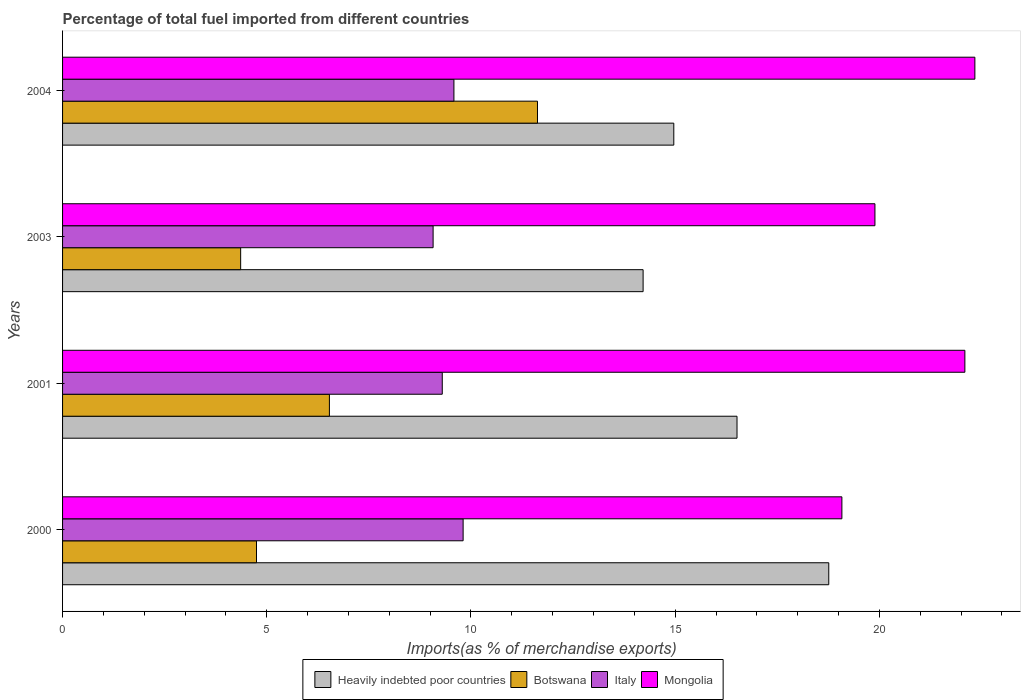How many different coloured bars are there?
Provide a short and direct response. 4. How many groups of bars are there?
Your answer should be very brief. 4. Are the number of bars per tick equal to the number of legend labels?
Provide a short and direct response. Yes. Are the number of bars on each tick of the Y-axis equal?
Give a very brief answer. Yes. What is the label of the 1st group of bars from the top?
Make the answer very short. 2004. What is the percentage of imports to different countries in Botswana in 2000?
Your response must be concise. 4.75. Across all years, what is the maximum percentage of imports to different countries in Mongolia?
Offer a very short reply. 22.34. Across all years, what is the minimum percentage of imports to different countries in Heavily indebted poor countries?
Keep it short and to the point. 14.21. What is the total percentage of imports to different countries in Heavily indebted poor countries in the graph?
Make the answer very short. 64.46. What is the difference between the percentage of imports to different countries in Mongolia in 2001 and that in 2004?
Your answer should be compact. -0.25. What is the difference between the percentage of imports to different countries in Mongolia in 2004 and the percentage of imports to different countries in Botswana in 2003?
Make the answer very short. 17.98. What is the average percentage of imports to different countries in Botswana per year?
Provide a succinct answer. 6.82. In the year 2000, what is the difference between the percentage of imports to different countries in Botswana and percentage of imports to different countries in Italy?
Your response must be concise. -5.06. What is the ratio of the percentage of imports to different countries in Heavily indebted poor countries in 2000 to that in 2001?
Give a very brief answer. 1.14. What is the difference between the highest and the second highest percentage of imports to different countries in Italy?
Provide a succinct answer. 0.23. What is the difference between the highest and the lowest percentage of imports to different countries in Heavily indebted poor countries?
Give a very brief answer. 4.55. Is the sum of the percentage of imports to different countries in Italy in 2003 and 2004 greater than the maximum percentage of imports to different countries in Mongolia across all years?
Provide a succinct answer. No. Is it the case that in every year, the sum of the percentage of imports to different countries in Botswana and percentage of imports to different countries in Italy is greater than the sum of percentage of imports to different countries in Mongolia and percentage of imports to different countries in Heavily indebted poor countries?
Offer a very short reply. No. What does the 3rd bar from the top in 2004 represents?
Make the answer very short. Botswana. What does the 1st bar from the bottom in 2001 represents?
Your answer should be compact. Heavily indebted poor countries. Are all the bars in the graph horizontal?
Your answer should be compact. Yes. Are the values on the major ticks of X-axis written in scientific E-notation?
Provide a succinct answer. No. Does the graph contain any zero values?
Offer a very short reply. No. Where does the legend appear in the graph?
Offer a very short reply. Bottom center. How many legend labels are there?
Provide a short and direct response. 4. What is the title of the graph?
Your response must be concise. Percentage of total fuel imported from different countries. What is the label or title of the X-axis?
Your answer should be compact. Imports(as % of merchandise exports). What is the Imports(as % of merchandise exports) of Heavily indebted poor countries in 2000?
Keep it short and to the point. 18.76. What is the Imports(as % of merchandise exports) in Botswana in 2000?
Your answer should be compact. 4.75. What is the Imports(as % of merchandise exports) of Italy in 2000?
Offer a very short reply. 9.81. What is the Imports(as % of merchandise exports) of Mongolia in 2000?
Provide a succinct answer. 19.08. What is the Imports(as % of merchandise exports) of Heavily indebted poor countries in 2001?
Keep it short and to the point. 16.51. What is the Imports(as % of merchandise exports) in Botswana in 2001?
Make the answer very short. 6.53. What is the Imports(as % of merchandise exports) of Italy in 2001?
Make the answer very short. 9.3. What is the Imports(as % of merchandise exports) in Mongolia in 2001?
Give a very brief answer. 22.09. What is the Imports(as % of merchandise exports) of Heavily indebted poor countries in 2003?
Keep it short and to the point. 14.21. What is the Imports(as % of merchandise exports) of Botswana in 2003?
Give a very brief answer. 4.36. What is the Imports(as % of merchandise exports) in Italy in 2003?
Your answer should be very brief. 9.07. What is the Imports(as % of merchandise exports) in Mongolia in 2003?
Keep it short and to the point. 19.89. What is the Imports(as % of merchandise exports) in Heavily indebted poor countries in 2004?
Make the answer very short. 14.97. What is the Imports(as % of merchandise exports) of Botswana in 2004?
Ensure brevity in your answer.  11.63. What is the Imports(as % of merchandise exports) of Italy in 2004?
Ensure brevity in your answer.  9.58. What is the Imports(as % of merchandise exports) in Mongolia in 2004?
Provide a succinct answer. 22.34. Across all years, what is the maximum Imports(as % of merchandise exports) of Heavily indebted poor countries?
Offer a terse response. 18.76. Across all years, what is the maximum Imports(as % of merchandise exports) of Botswana?
Your answer should be compact. 11.63. Across all years, what is the maximum Imports(as % of merchandise exports) of Italy?
Your answer should be very brief. 9.81. Across all years, what is the maximum Imports(as % of merchandise exports) in Mongolia?
Ensure brevity in your answer.  22.34. Across all years, what is the minimum Imports(as % of merchandise exports) of Heavily indebted poor countries?
Keep it short and to the point. 14.21. Across all years, what is the minimum Imports(as % of merchandise exports) in Botswana?
Your answer should be compact. 4.36. Across all years, what is the minimum Imports(as % of merchandise exports) of Italy?
Give a very brief answer. 9.07. Across all years, what is the minimum Imports(as % of merchandise exports) in Mongolia?
Provide a succinct answer. 19.08. What is the total Imports(as % of merchandise exports) in Heavily indebted poor countries in the graph?
Offer a terse response. 64.46. What is the total Imports(as % of merchandise exports) of Botswana in the graph?
Keep it short and to the point. 27.27. What is the total Imports(as % of merchandise exports) in Italy in the graph?
Keep it short and to the point. 37.76. What is the total Imports(as % of merchandise exports) in Mongolia in the graph?
Your answer should be very brief. 83.41. What is the difference between the Imports(as % of merchandise exports) of Heavily indebted poor countries in 2000 and that in 2001?
Keep it short and to the point. 2.25. What is the difference between the Imports(as % of merchandise exports) in Botswana in 2000 and that in 2001?
Your answer should be compact. -1.79. What is the difference between the Imports(as % of merchandise exports) in Italy in 2000 and that in 2001?
Keep it short and to the point. 0.51. What is the difference between the Imports(as % of merchandise exports) of Mongolia in 2000 and that in 2001?
Provide a succinct answer. -3.01. What is the difference between the Imports(as % of merchandise exports) in Heavily indebted poor countries in 2000 and that in 2003?
Your answer should be compact. 4.55. What is the difference between the Imports(as % of merchandise exports) in Botswana in 2000 and that in 2003?
Ensure brevity in your answer.  0.39. What is the difference between the Imports(as % of merchandise exports) in Italy in 2000 and that in 2003?
Offer a very short reply. 0.74. What is the difference between the Imports(as % of merchandise exports) in Mongolia in 2000 and that in 2003?
Offer a terse response. -0.81. What is the difference between the Imports(as % of merchandise exports) of Heavily indebted poor countries in 2000 and that in 2004?
Your response must be concise. 3.79. What is the difference between the Imports(as % of merchandise exports) of Botswana in 2000 and that in 2004?
Your answer should be compact. -6.88. What is the difference between the Imports(as % of merchandise exports) in Italy in 2000 and that in 2004?
Your answer should be very brief. 0.23. What is the difference between the Imports(as % of merchandise exports) in Mongolia in 2000 and that in 2004?
Offer a very short reply. -3.26. What is the difference between the Imports(as % of merchandise exports) in Heavily indebted poor countries in 2001 and that in 2003?
Your answer should be very brief. 2.3. What is the difference between the Imports(as % of merchandise exports) of Botswana in 2001 and that in 2003?
Your answer should be very brief. 2.17. What is the difference between the Imports(as % of merchandise exports) in Italy in 2001 and that in 2003?
Keep it short and to the point. 0.22. What is the difference between the Imports(as % of merchandise exports) in Mongolia in 2001 and that in 2003?
Provide a succinct answer. 2.2. What is the difference between the Imports(as % of merchandise exports) of Heavily indebted poor countries in 2001 and that in 2004?
Provide a short and direct response. 1.55. What is the difference between the Imports(as % of merchandise exports) in Botswana in 2001 and that in 2004?
Make the answer very short. -5.09. What is the difference between the Imports(as % of merchandise exports) of Italy in 2001 and that in 2004?
Keep it short and to the point. -0.29. What is the difference between the Imports(as % of merchandise exports) of Mongolia in 2001 and that in 2004?
Keep it short and to the point. -0.24. What is the difference between the Imports(as % of merchandise exports) in Heavily indebted poor countries in 2003 and that in 2004?
Offer a very short reply. -0.75. What is the difference between the Imports(as % of merchandise exports) of Botswana in 2003 and that in 2004?
Your answer should be very brief. -7.27. What is the difference between the Imports(as % of merchandise exports) of Italy in 2003 and that in 2004?
Your answer should be compact. -0.51. What is the difference between the Imports(as % of merchandise exports) of Mongolia in 2003 and that in 2004?
Provide a succinct answer. -2.45. What is the difference between the Imports(as % of merchandise exports) in Heavily indebted poor countries in 2000 and the Imports(as % of merchandise exports) in Botswana in 2001?
Your answer should be very brief. 12.23. What is the difference between the Imports(as % of merchandise exports) in Heavily indebted poor countries in 2000 and the Imports(as % of merchandise exports) in Italy in 2001?
Provide a succinct answer. 9.46. What is the difference between the Imports(as % of merchandise exports) in Heavily indebted poor countries in 2000 and the Imports(as % of merchandise exports) in Mongolia in 2001?
Provide a succinct answer. -3.33. What is the difference between the Imports(as % of merchandise exports) in Botswana in 2000 and the Imports(as % of merchandise exports) in Italy in 2001?
Offer a very short reply. -4.55. What is the difference between the Imports(as % of merchandise exports) in Botswana in 2000 and the Imports(as % of merchandise exports) in Mongolia in 2001?
Ensure brevity in your answer.  -17.34. What is the difference between the Imports(as % of merchandise exports) in Italy in 2000 and the Imports(as % of merchandise exports) in Mongolia in 2001?
Provide a short and direct response. -12.29. What is the difference between the Imports(as % of merchandise exports) in Heavily indebted poor countries in 2000 and the Imports(as % of merchandise exports) in Botswana in 2003?
Your answer should be very brief. 14.4. What is the difference between the Imports(as % of merchandise exports) in Heavily indebted poor countries in 2000 and the Imports(as % of merchandise exports) in Italy in 2003?
Make the answer very short. 9.69. What is the difference between the Imports(as % of merchandise exports) in Heavily indebted poor countries in 2000 and the Imports(as % of merchandise exports) in Mongolia in 2003?
Offer a terse response. -1.13. What is the difference between the Imports(as % of merchandise exports) in Botswana in 2000 and the Imports(as % of merchandise exports) in Italy in 2003?
Provide a short and direct response. -4.32. What is the difference between the Imports(as % of merchandise exports) in Botswana in 2000 and the Imports(as % of merchandise exports) in Mongolia in 2003?
Provide a short and direct response. -15.14. What is the difference between the Imports(as % of merchandise exports) of Italy in 2000 and the Imports(as % of merchandise exports) of Mongolia in 2003?
Offer a very short reply. -10.08. What is the difference between the Imports(as % of merchandise exports) of Heavily indebted poor countries in 2000 and the Imports(as % of merchandise exports) of Botswana in 2004?
Keep it short and to the point. 7.13. What is the difference between the Imports(as % of merchandise exports) of Heavily indebted poor countries in 2000 and the Imports(as % of merchandise exports) of Italy in 2004?
Ensure brevity in your answer.  9.18. What is the difference between the Imports(as % of merchandise exports) in Heavily indebted poor countries in 2000 and the Imports(as % of merchandise exports) in Mongolia in 2004?
Your answer should be compact. -3.58. What is the difference between the Imports(as % of merchandise exports) of Botswana in 2000 and the Imports(as % of merchandise exports) of Italy in 2004?
Your answer should be compact. -4.83. What is the difference between the Imports(as % of merchandise exports) in Botswana in 2000 and the Imports(as % of merchandise exports) in Mongolia in 2004?
Keep it short and to the point. -17.59. What is the difference between the Imports(as % of merchandise exports) of Italy in 2000 and the Imports(as % of merchandise exports) of Mongolia in 2004?
Give a very brief answer. -12.53. What is the difference between the Imports(as % of merchandise exports) of Heavily indebted poor countries in 2001 and the Imports(as % of merchandise exports) of Botswana in 2003?
Make the answer very short. 12.15. What is the difference between the Imports(as % of merchandise exports) in Heavily indebted poor countries in 2001 and the Imports(as % of merchandise exports) in Italy in 2003?
Give a very brief answer. 7.44. What is the difference between the Imports(as % of merchandise exports) of Heavily indebted poor countries in 2001 and the Imports(as % of merchandise exports) of Mongolia in 2003?
Ensure brevity in your answer.  -3.38. What is the difference between the Imports(as % of merchandise exports) in Botswana in 2001 and the Imports(as % of merchandise exports) in Italy in 2003?
Give a very brief answer. -2.54. What is the difference between the Imports(as % of merchandise exports) in Botswana in 2001 and the Imports(as % of merchandise exports) in Mongolia in 2003?
Your response must be concise. -13.36. What is the difference between the Imports(as % of merchandise exports) in Italy in 2001 and the Imports(as % of merchandise exports) in Mongolia in 2003?
Make the answer very short. -10.59. What is the difference between the Imports(as % of merchandise exports) in Heavily indebted poor countries in 2001 and the Imports(as % of merchandise exports) in Botswana in 2004?
Ensure brevity in your answer.  4.89. What is the difference between the Imports(as % of merchandise exports) in Heavily indebted poor countries in 2001 and the Imports(as % of merchandise exports) in Italy in 2004?
Give a very brief answer. 6.93. What is the difference between the Imports(as % of merchandise exports) of Heavily indebted poor countries in 2001 and the Imports(as % of merchandise exports) of Mongolia in 2004?
Your response must be concise. -5.82. What is the difference between the Imports(as % of merchandise exports) in Botswana in 2001 and the Imports(as % of merchandise exports) in Italy in 2004?
Your answer should be very brief. -3.05. What is the difference between the Imports(as % of merchandise exports) of Botswana in 2001 and the Imports(as % of merchandise exports) of Mongolia in 2004?
Your answer should be compact. -15.8. What is the difference between the Imports(as % of merchandise exports) of Italy in 2001 and the Imports(as % of merchandise exports) of Mongolia in 2004?
Your response must be concise. -13.04. What is the difference between the Imports(as % of merchandise exports) of Heavily indebted poor countries in 2003 and the Imports(as % of merchandise exports) of Botswana in 2004?
Your answer should be very brief. 2.59. What is the difference between the Imports(as % of merchandise exports) in Heavily indebted poor countries in 2003 and the Imports(as % of merchandise exports) in Italy in 2004?
Offer a terse response. 4.63. What is the difference between the Imports(as % of merchandise exports) in Heavily indebted poor countries in 2003 and the Imports(as % of merchandise exports) in Mongolia in 2004?
Your response must be concise. -8.12. What is the difference between the Imports(as % of merchandise exports) of Botswana in 2003 and the Imports(as % of merchandise exports) of Italy in 2004?
Give a very brief answer. -5.22. What is the difference between the Imports(as % of merchandise exports) in Botswana in 2003 and the Imports(as % of merchandise exports) in Mongolia in 2004?
Keep it short and to the point. -17.98. What is the difference between the Imports(as % of merchandise exports) in Italy in 2003 and the Imports(as % of merchandise exports) in Mongolia in 2004?
Provide a short and direct response. -13.27. What is the average Imports(as % of merchandise exports) in Heavily indebted poor countries per year?
Offer a terse response. 16.11. What is the average Imports(as % of merchandise exports) in Botswana per year?
Ensure brevity in your answer.  6.82. What is the average Imports(as % of merchandise exports) of Italy per year?
Your response must be concise. 9.44. What is the average Imports(as % of merchandise exports) of Mongolia per year?
Give a very brief answer. 20.85. In the year 2000, what is the difference between the Imports(as % of merchandise exports) of Heavily indebted poor countries and Imports(as % of merchandise exports) of Botswana?
Provide a short and direct response. 14.01. In the year 2000, what is the difference between the Imports(as % of merchandise exports) in Heavily indebted poor countries and Imports(as % of merchandise exports) in Italy?
Your answer should be compact. 8.95. In the year 2000, what is the difference between the Imports(as % of merchandise exports) of Heavily indebted poor countries and Imports(as % of merchandise exports) of Mongolia?
Provide a succinct answer. -0.32. In the year 2000, what is the difference between the Imports(as % of merchandise exports) in Botswana and Imports(as % of merchandise exports) in Italy?
Your answer should be very brief. -5.06. In the year 2000, what is the difference between the Imports(as % of merchandise exports) of Botswana and Imports(as % of merchandise exports) of Mongolia?
Your answer should be very brief. -14.33. In the year 2000, what is the difference between the Imports(as % of merchandise exports) in Italy and Imports(as % of merchandise exports) in Mongolia?
Make the answer very short. -9.27. In the year 2001, what is the difference between the Imports(as % of merchandise exports) in Heavily indebted poor countries and Imports(as % of merchandise exports) in Botswana?
Ensure brevity in your answer.  9.98. In the year 2001, what is the difference between the Imports(as % of merchandise exports) of Heavily indebted poor countries and Imports(as % of merchandise exports) of Italy?
Give a very brief answer. 7.22. In the year 2001, what is the difference between the Imports(as % of merchandise exports) in Heavily indebted poor countries and Imports(as % of merchandise exports) in Mongolia?
Your response must be concise. -5.58. In the year 2001, what is the difference between the Imports(as % of merchandise exports) in Botswana and Imports(as % of merchandise exports) in Italy?
Your answer should be very brief. -2.76. In the year 2001, what is the difference between the Imports(as % of merchandise exports) in Botswana and Imports(as % of merchandise exports) in Mongolia?
Ensure brevity in your answer.  -15.56. In the year 2001, what is the difference between the Imports(as % of merchandise exports) of Italy and Imports(as % of merchandise exports) of Mongolia?
Give a very brief answer. -12.8. In the year 2003, what is the difference between the Imports(as % of merchandise exports) in Heavily indebted poor countries and Imports(as % of merchandise exports) in Botswana?
Give a very brief answer. 9.85. In the year 2003, what is the difference between the Imports(as % of merchandise exports) of Heavily indebted poor countries and Imports(as % of merchandise exports) of Italy?
Provide a succinct answer. 5.14. In the year 2003, what is the difference between the Imports(as % of merchandise exports) in Heavily indebted poor countries and Imports(as % of merchandise exports) in Mongolia?
Offer a terse response. -5.68. In the year 2003, what is the difference between the Imports(as % of merchandise exports) of Botswana and Imports(as % of merchandise exports) of Italy?
Offer a very short reply. -4.71. In the year 2003, what is the difference between the Imports(as % of merchandise exports) in Botswana and Imports(as % of merchandise exports) in Mongolia?
Give a very brief answer. -15.53. In the year 2003, what is the difference between the Imports(as % of merchandise exports) in Italy and Imports(as % of merchandise exports) in Mongolia?
Your answer should be compact. -10.82. In the year 2004, what is the difference between the Imports(as % of merchandise exports) in Heavily indebted poor countries and Imports(as % of merchandise exports) in Botswana?
Provide a succinct answer. 3.34. In the year 2004, what is the difference between the Imports(as % of merchandise exports) in Heavily indebted poor countries and Imports(as % of merchandise exports) in Italy?
Keep it short and to the point. 5.38. In the year 2004, what is the difference between the Imports(as % of merchandise exports) of Heavily indebted poor countries and Imports(as % of merchandise exports) of Mongolia?
Offer a terse response. -7.37. In the year 2004, what is the difference between the Imports(as % of merchandise exports) in Botswana and Imports(as % of merchandise exports) in Italy?
Your answer should be compact. 2.05. In the year 2004, what is the difference between the Imports(as % of merchandise exports) of Botswana and Imports(as % of merchandise exports) of Mongolia?
Give a very brief answer. -10.71. In the year 2004, what is the difference between the Imports(as % of merchandise exports) of Italy and Imports(as % of merchandise exports) of Mongolia?
Make the answer very short. -12.76. What is the ratio of the Imports(as % of merchandise exports) in Heavily indebted poor countries in 2000 to that in 2001?
Make the answer very short. 1.14. What is the ratio of the Imports(as % of merchandise exports) in Botswana in 2000 to that in 2001?
Make the answer very short. 0.73. What is the ratio of the Imports(as % of merchandise exports) in Italy in 2000 to that in 2001?
Make the answer very short. 1.05. What is the ratio of the Imports(as % of merchandise exports) of Mongolia in 2000 to that in 2001?
Offer a very short reply. 0.86. What is the ratio of the Imports(as % of merchandise exports) in Heavily indebted poor countries in 2000 to that in 2003?
Your response must be concise. 1.32. What is the ratio of the Imports(as % of merchandise exports) of Botswana in 2000 to that in 2003?
Your answer should be compact. 1.09. What is the ratio of the Imports(as % of merchandise exports) of Italy in 2000 to that in 2003?
Offer a terse response. 1.08. What is the ratio of the Imports(as % of merchandise exports) of Mongolia in 2000 to that in 2003?
Your response must be concise. 0.96. What is the ratio of the Imports(as % of merchandise exports) of Heavily indebted poor countries in 2000 to that in 2004?
Offer a very short reply. 1.25. What is the ratio of the Imports(as % of merchandise exports) of Botswana in 2000 to that in 2004?
Your answer should be compact. 0.41. What is the ratio of the Imports(as % of merchandise exports) in Italy in 2000 to that in 2004?
Offer a terse response. 1.02. What is the ratio of the Imports(as % of merchandise exports) in Mongolia in 2000 to that in 2004?
Your response must be concise. 0.85. What is the ratio of the Imports(as % of merchandise exports) of Heavily indebted poor countries in 2001 to that in 2003?
Give a very brief answer. 1.16. What is the ratio of the Imports(as % of merchandise exports) of Botswana in 2001 to that in 2003?
Your response must be concise. 1.5. What is the ratio of the Imports(as % of merchandise exports) of Italy in 2001 to that in 2003?
Provide a succinct answer. 1.02. What is the ratio of the Imports(as % of merchandise exports) in Mongolia in 2001 to that in 2003?
Provide a succinct answer. 1.11. What is the ratio of the Imports(as % of merchandise exports) of Heavily indebted poor countries in 2001 to that in 2004?
Keep it short and to the point. 1.1. What is the ratio of the Imports(as % of merchandise exports) in Botswana in 2001 to that in 2004?
Your response must be concise. 0.56. What is the ratio of the Imports(as % of merchandise exports) in Italy in 2001 to that in 2004?
Your response must be concise. 0.97. What is the ratio of the Imports(as % of merchandise exports) of Mongolia in 2001 to that in 2004?
Provide a succinct answer. 0.99. What is the ratio of the Imports(as % of merchandise exports) of Heavily indebted poor countries in 2003 to that in 2004?
Provide a short and direct response. 0.95. What is the ratio of the Imports(as % of merchandise exports) of Italy in 2003 to that in 2004?
Your response must be concise. 0.95. What is the ratio of the Imports(as % of merchandise exports) of Mongolia in 2003 to that in 2004?
Ensure brevity in your answer.  0.89. What is the difference between the highest and the second highest Imports(as % of merchandise exports) in Heavily indebted poor countries?
Your answer should be compact. 2.25. What is the difference between the highest and the second highest Imports(as % of merchandise exports) of Botswana?
Keep it short and to the point. 5.09. What is the difference between the highest and the second highest Imports(as % of merchandise exports) of Italy?
Keep it short and to the point. 0.23. What is the difference between the highest and the second highest Imports(as % of merchandise exports) of Mongolia?
Ensure brevity in your answer.  0.24. What is the difference between the highest and the lowest Imports(as % of merchandise exports) in Heavily indebted poor countries?
Give a very brief answer. 4.55. What is the difference between the highest and the lowest Imports(as % of merchandise exports) of Botswana?
Your response must be concise. 7.27. What is the difference between the highest and the lowest Imports(as % of merchandise exports) of Italy?
Offer a very short reply. 0.74. What is the difference between the highest and the lowest Imports(as % of merchandise exports) in Mongolia?
Provide a succinct answer. 3.26. 